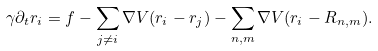<formula> <loc_0><loc_0><loc_500><loc_500>\gamma \partial _ { t } { r } _ { i } = f - \sum _ { j \neq i } \nabla V ( { r } _ { i } - { r } _ { j } ) - \sum _ { n , m } \nabla V ( { r } _ { i } - { R } _ { n , m } ) .</formula> 